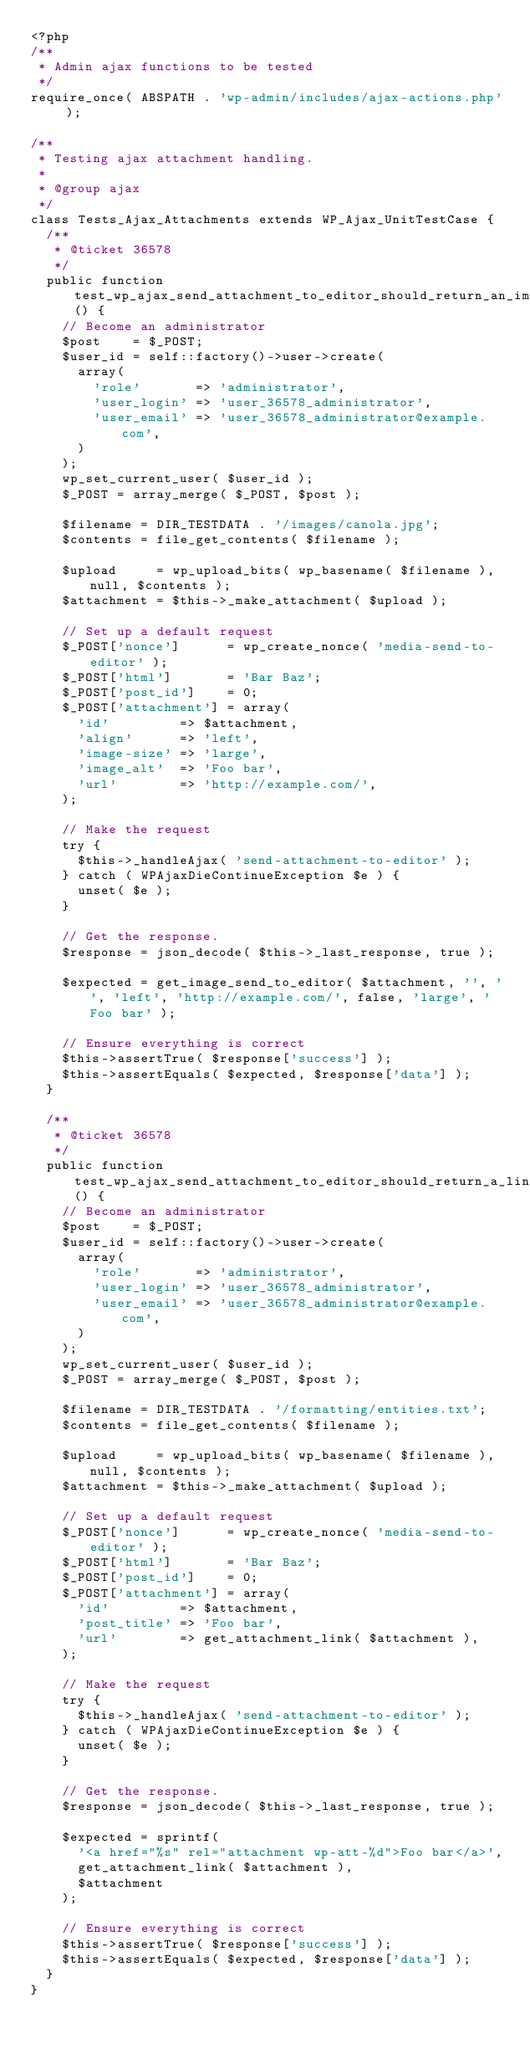<code> <loc_0><loc_0><loc_500><loc_500><_PHP_><?php
/**
 * Admin ajax functions to be tested
 */
require_once( ABSPATH . 'wp-admin/includes/ajax-actions.php' );

/**
 * Testing ajax attachment handling.
 *
 * @group ajax
 */
class Tests_Ajax_Attachments extends WP_Ajax_UnitTestCase {
	/**
	 * @ticket 36578
	 */
	public function test_wp_ajax_send_attachment_to_editor_should_return_an_image() {
		// Become an administrator
		$post    = $_POST;
		$user_id = self::factory()->user->create(
			array(
				'role'       => 'administrator',
				'user_login' => 'user_36578_administrator',
				'user_email' => 'user_36578_administrator@example.com',
			)
		);
		wp_set_current_user( $user_id );
		$_POST = array_merge( $_POST, $post );

		$filename = DIR_TESTDATA . '/images/canola.jpg';
		$contents = file_get_contents( $filename );

		$upload     = wp_upload_bits( wp_basename( $filename ), null, $contents );
		$attachment = $this->_make_attachment( $upload );

		// Set up a default request
		$_POST['nonce']      = wp_create_nonce( 'media-send-to-editor' );
		$_POST['html']       = 'Bar Baz';
		$_POST['post_id']    = 0;
		$_POST['attachment'] = array(
			'id'         => $attachment,
			'align'      => 'left',
			'image-size' => 'large',
			'image_alt'  => 'Foo bar',
			'url'        => 'http://example.com/',
		);

		// Make the request
		try {
			$this->_handleAjax( 'send-attachment-to-editor' );
		} catch ( WPAjaxDieContinueException $e ) {
			unset( $e );
		}

		// Get the response.
		$response = json_decode( $this->_last_response, true );

		$expected = get_image_send_to_editor( $attachment, '', '', 'left', 'http://example.com/', false, 'large', 'Foo bar' );

		// Ensure everything is correct
		$this->assertTrue( $response['success'] );
		$this->assertEquals( $expected, $response['data'] );
	}

	/**
	 * @ticket 36578
	 */
	public function test_wp_ajax_send_attachment_to_editor_should_return_a_link() {
		// Become an administrator
		$post    = $_POST;
		$user_id = self::factory()->user->create(
			array(
				'role'       => 'administrator',
				'user_login' => 'user_36578_administrator',
				'user_email' => 'user_36578_administrator@example.com',
			)
		);
		wp_set_current_user( $user_id );
		$_POST = array_merge( $_POST, $post );

		$filename = DIR_TESTDATA . '/formatting/entities.txt';
		$contents = file_get_contents( $filename );

		$upload     = wp_upload_bits( wp_basename( $filename ), null, $contents );
		$attachment = $this->_make_attachment( $upload );

		// Set up a default request
		$_POST['nonce']      = wp_create_nonce( 'media-send-to-editor' );
		$_POST['html']       = 'Bar Baz';
		$_POST['post_id']    = 0;
		$_POST['attachment'] = array(
			'id'         => $attachment,
			'post_title' => 'Foo bar',
			'url'        => get_attachment_link( $attachment ),
		);

		// Make the request
		try {
			$this->_handleAjax( 'send-attachment-to-editor' );
		} catch ( WPAjaxDieContinueException $e ) {
			unset( $e );
		}

		// Get the response.
		$response = json_decode( $this->_last_response, true );

		$expected = sprintf(
			'<a href="%s" rel="attachment wp-att-%d">Foo bar</a>',
			get_attachment_link( $attachment ),
			$attachment
		);

		// Ensure everything is correct
		$this->assertTrue( $response['success'] );
		$this->assertEquals( $expected, $response['data'] );
	}
}
</code> 